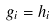<formula> <loc_0><loc_0><loc_500><loc_500>g _ { i } = h _ { i }</formula> 